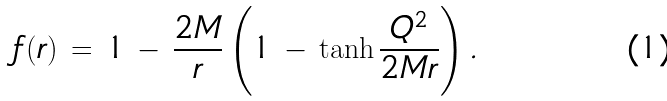Convert formula to latex. <formula><loc_0><loc_0><loc_500><loc_500>f ( r ) \, = \, 1 \, - \, \frac { 2 M } { r } \left ( 1 \, - \, \tanh \frac { Q ^ { 2 } } { 2 M r } \right ) .</formula> 